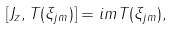Convert formula to latex. <formula><loc_0><loc_0><loc_500><loc_500>[ J _ { z } , T ( \xi _ { j m } ) ] = i m T ( \xi _ { j m } ) ,</formula> 